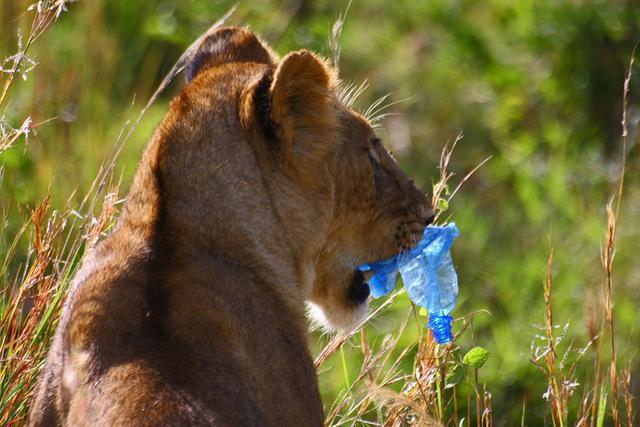How many people are on bicycles?
Give a very brief answer. 0. 